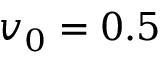<formula> <loc_0><loc_0><loc_500><loc_500>v _ { 0 } = 0 . 5</formula> 